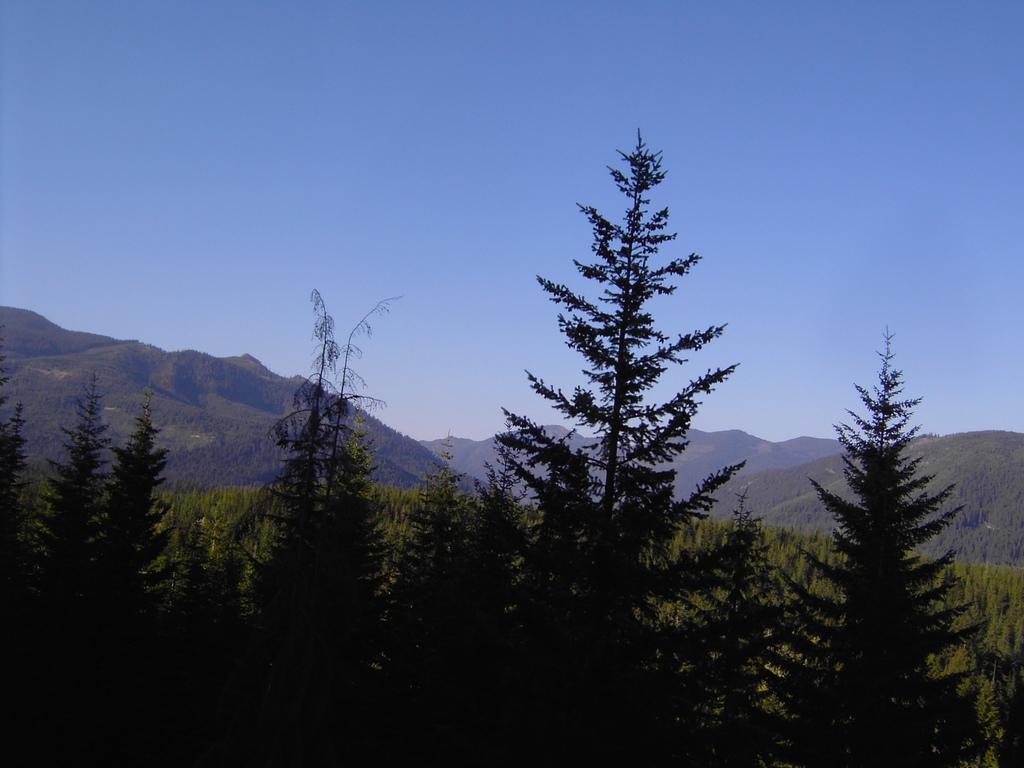How would you summarize this image in a sentence or two? In this image there are trees and mountains. 